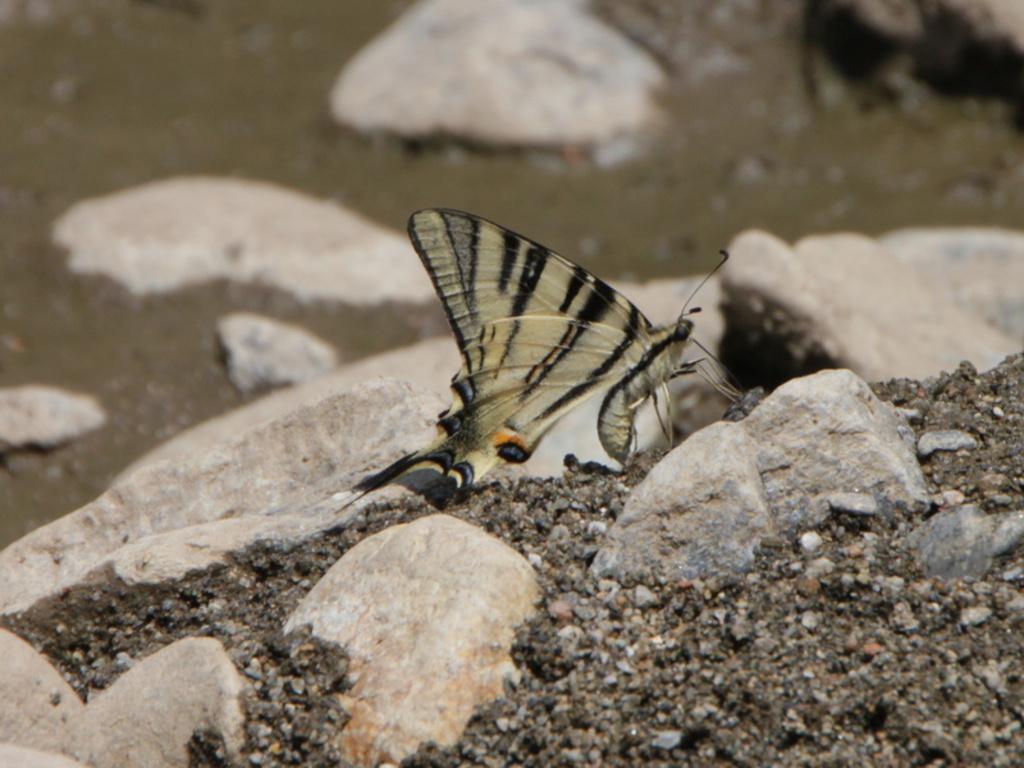Can you describe this image briefly? In this image I can see a butterfly which is cream, black, grey and orange in color on the rock. I can see few rocks and the ground. 